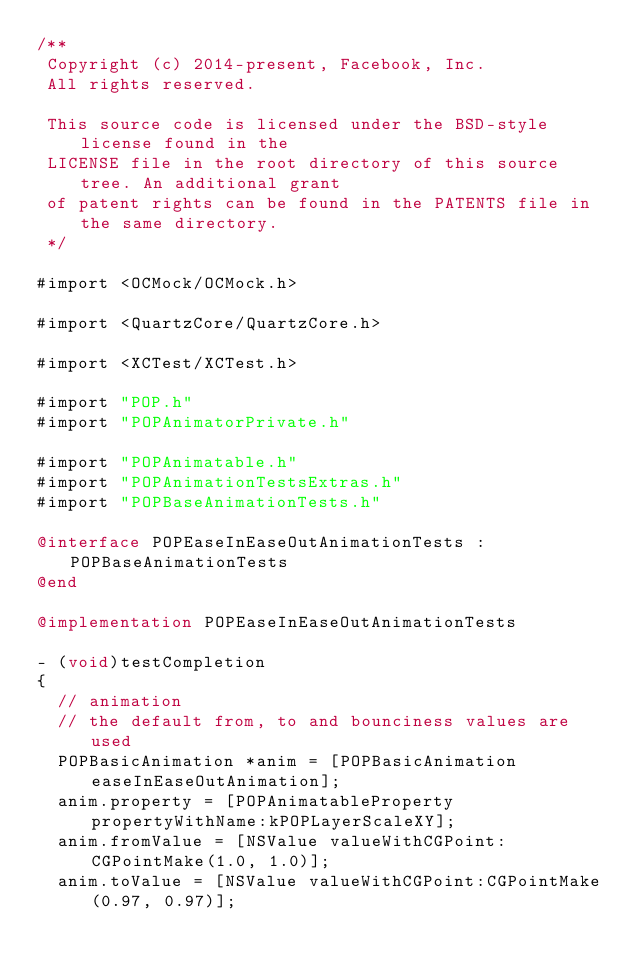Convert code to text. <code><loc_0><loc_0><loc_500><loc_500><_ObjectiveC_>/**
 Copyright (c) 2014-present, Facebook, Inc.
 All rights reserved.
 
 This source code is licensed under the BSD-style license found in the
 LICENSE file in the root directory of this source tree. An additional grant
 of patent rights can be found in the PATENTS file in the same directory.
 */

#import <OCMock/OCMock.h>

#import <QuartzCore/QuartzCore.h>

#import <XCTest/XCTest.h>

#import "POP.h"
#import "POPAnimatorPrivate.h"

#import "POPAnimatable.h"
#import "POPAnimationTestsExtras.h"
#import "POPBaseAnimationTests.h"

@interface POPEaseInEaseOutAnimationTests : POPBaseAnimationTests
@end

@implementation POPEaseInEaseOutAnimationTests

- (void)testCompletion
{
  // animation
  // the default from, to and bounciness values are used
  POPBasicAnimation *anim = [POPBasicAnimation easeInEaseOutAnimation];
  anim.property = [POPAnimatableProperty propertyWithName:kPOPLayerScaleXY];
  anim.fromValue = [NSValue valueWithCGPoint:CGPointMake(1.0, 1.0)];
  anim.toValue = [NSValue valueWithCGPoint:CGPointMake(0.97, 0.97)];
</code> 